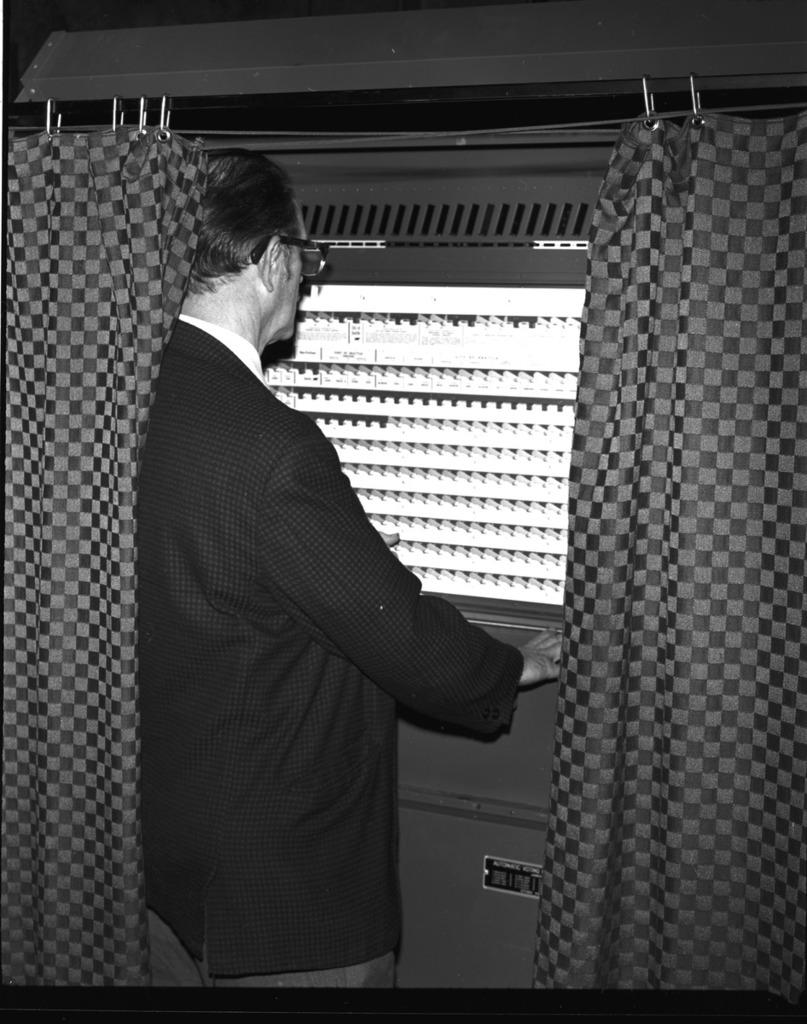What is the person in the image doing? The person is standing and looking outside through a window. What can be seen on the other side of the window? There is a cruise ship visible on the other side of the window. What is beside the person in the image? There are curtains beside the person. How many lizards are fighting with their mouths open in the image? There are no lizards present in the image, and therefore no such activity can be observed. 